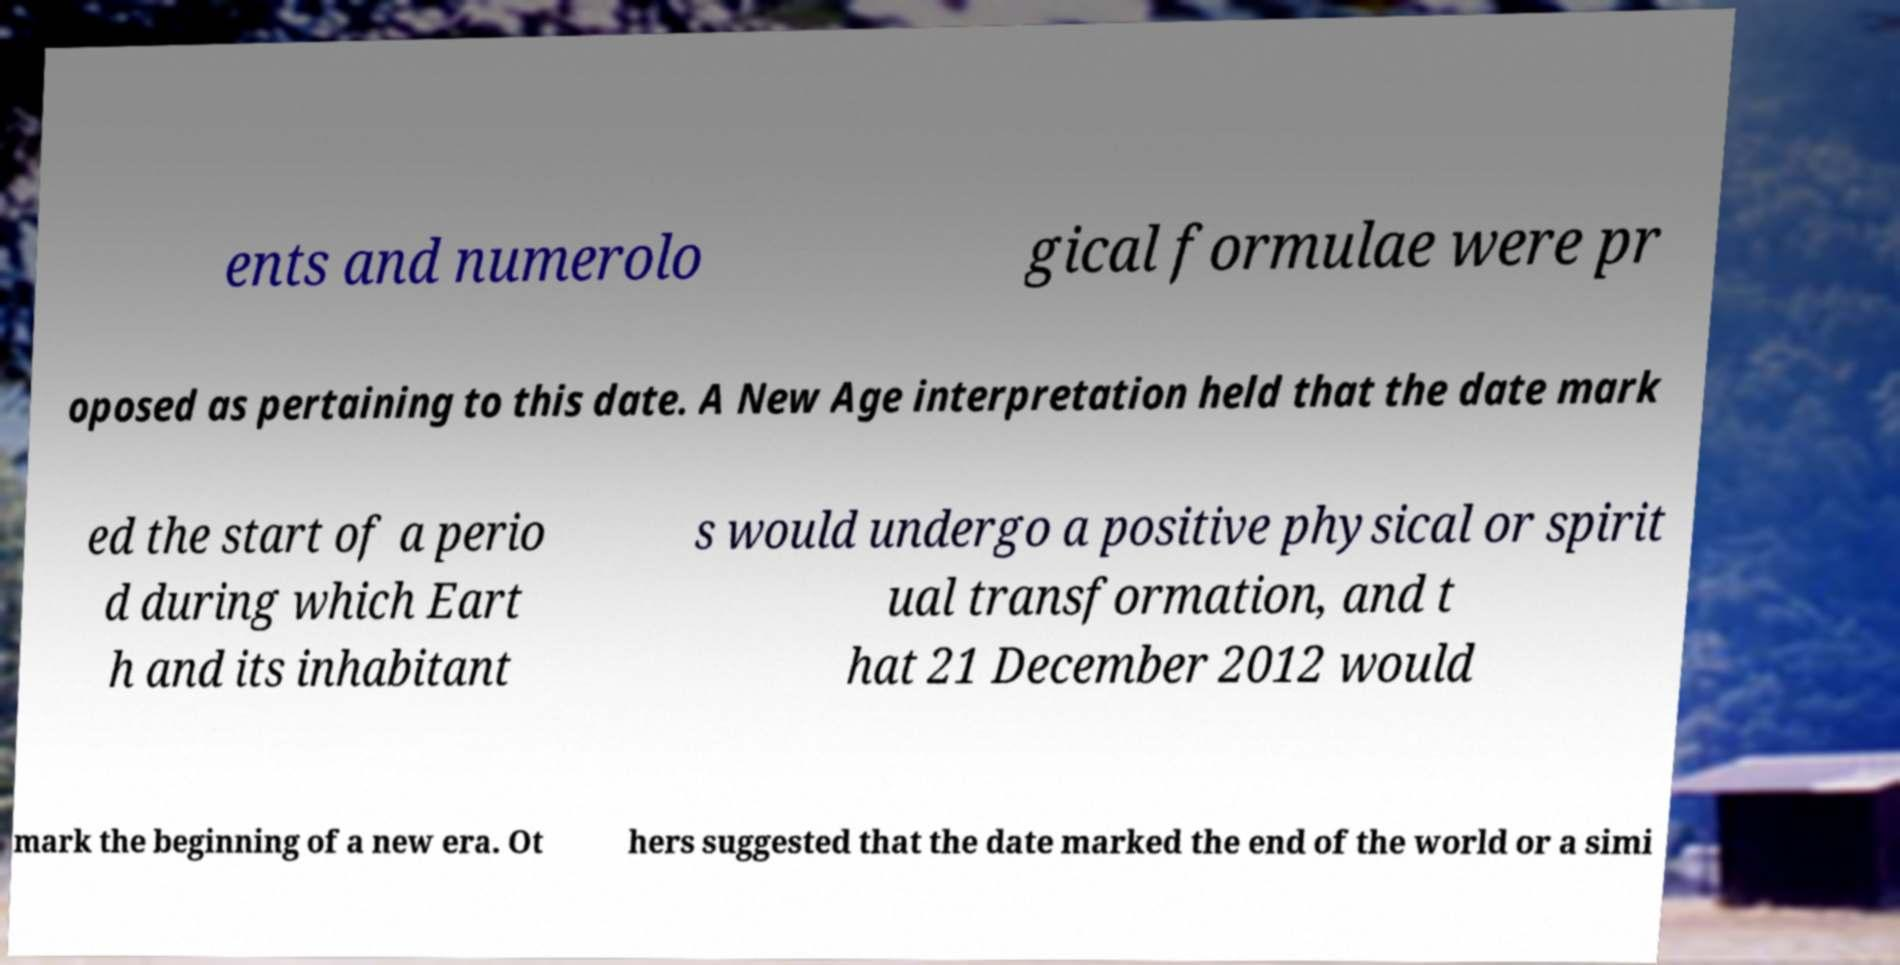Could you assist in decoding the text presented in this image and type it out clearly? ents and numerolo gical formulae were pr oposed as pertaining to this date. A New Age interpretation held that the date mark ed the start of a perio d during which Eart h and its inhabitant s would undergo a positive physical or spirit ual transformation, and t hat 21 December 2012 would mark the beginning of a new era. Ot hers suggested that the date marked the end of the world or a simi 